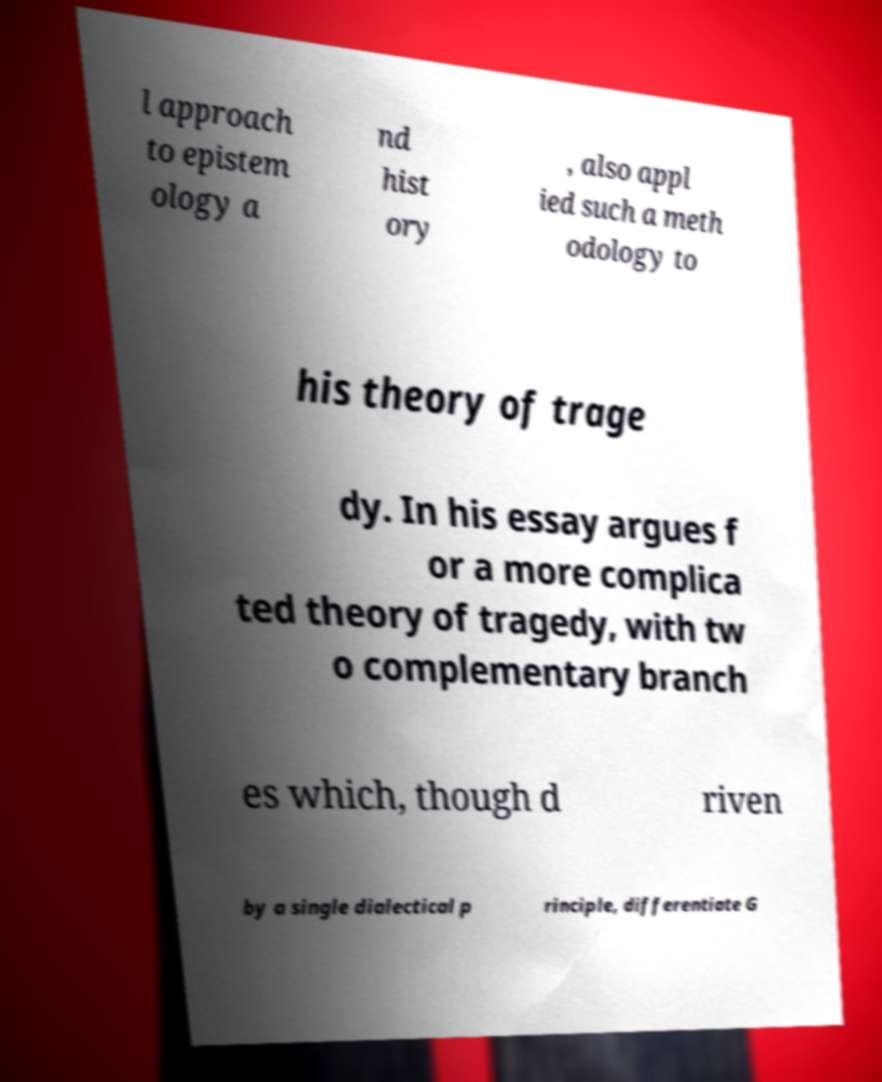Please read and relay the text visible in this image. What does it say? l approach to epistem ology a nd hist ory , also appl ied such a meth odology to his theory of trage dy. In his essay argues f or a more complica ted theory of tragedy, with tw o complementary branch es which, though d riven by a single dialectical p rinciple, differentiate G 